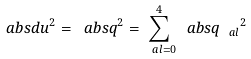<formula> <loc_0><loc_0><loc_500><loc_500>\ a b s { d u } ^ { 2 } = \ a b s { q } ^ { 2 } = \sum _ { \ a l = 0 } ^ { 4 } \ a b s { q _ { \ a l } } ^ { 2 }</formula> 